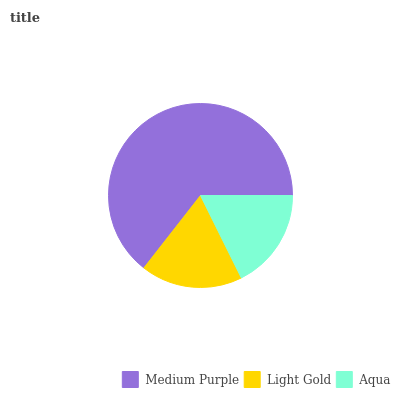Is Aqua the minimum?
Answer yes or no. Yes. Is Medium Purple the maximum?
Answer yes or no. Yes. Is Light Gold the minimum?
Answer yes or no. No. Is Light Gold the maximum?
Answer yes or no. No. Is Medium Purple greater than Light Gold?
Answer yes or no. Yes. Is Light Gold less than Medium Purple?
Answer yes or no. Yes. Is Light Gold greater than Medium Purple?
Answer yes or no. No. Is Medium Purple less than Light Gold?
Answer yes or no. No. Is Light Gold the high median?
Answer yes or no. Yes. Is Light Gold the low median?
Answer yes or no. Yes. Is Aqua the high median?
Answer yes or no. No. Is Aqua the low median?
Answer yes or no. No. 